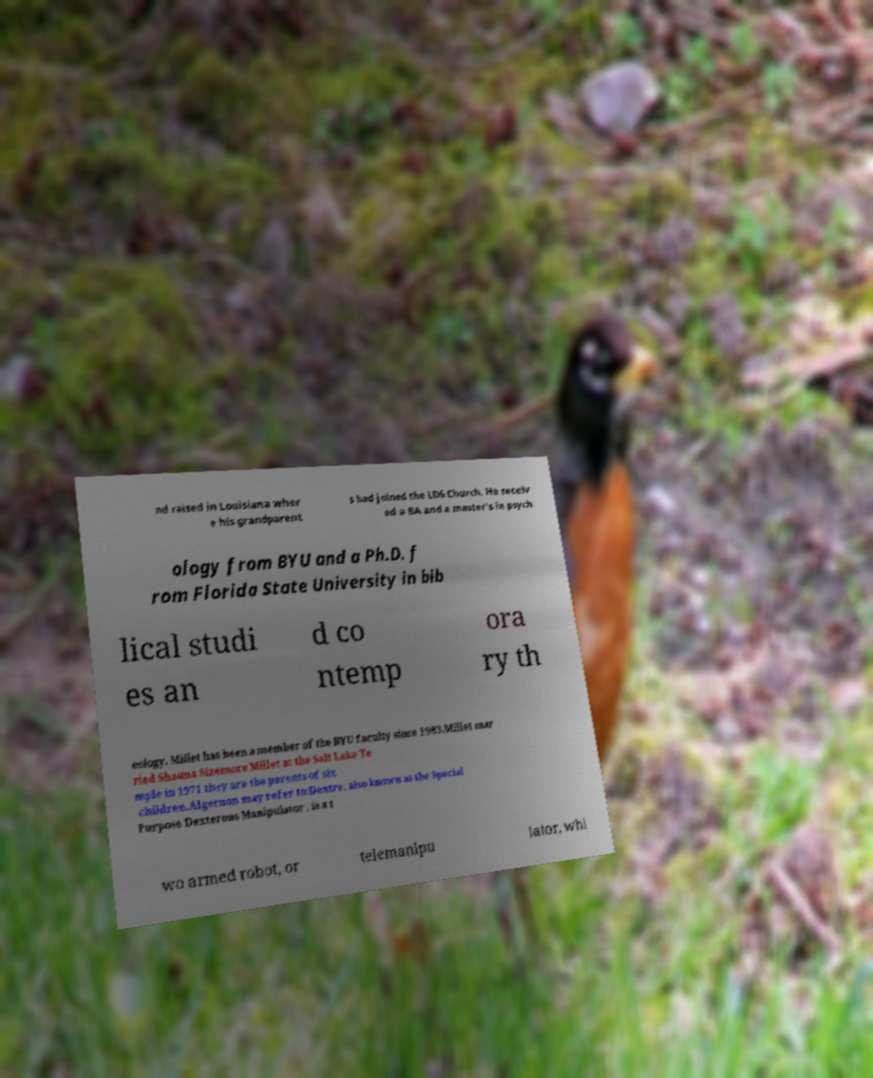For documentation purposes, I need the text within this image transcribed. Could you provide that? nd raised in Louisiana wher e his grandparent s had joined the LDS Church. He receiv ed a BA and a master's in psych ology from BYU and a Ph.D. f rom Florida State University in bib lical studi es an d co ntemp ora ry th eology. Millet has been a member of the BYU faculty since 1983.Millet mar ried Shauna Sizemore Millet at the Salt Lake Te mple in 1971 they are the parents of six children.Algernon may refer to:Dextre, also known as the Special Purpose Dexterous Manipulator , is a t wo armed robot, or telemanipu lator, whi 